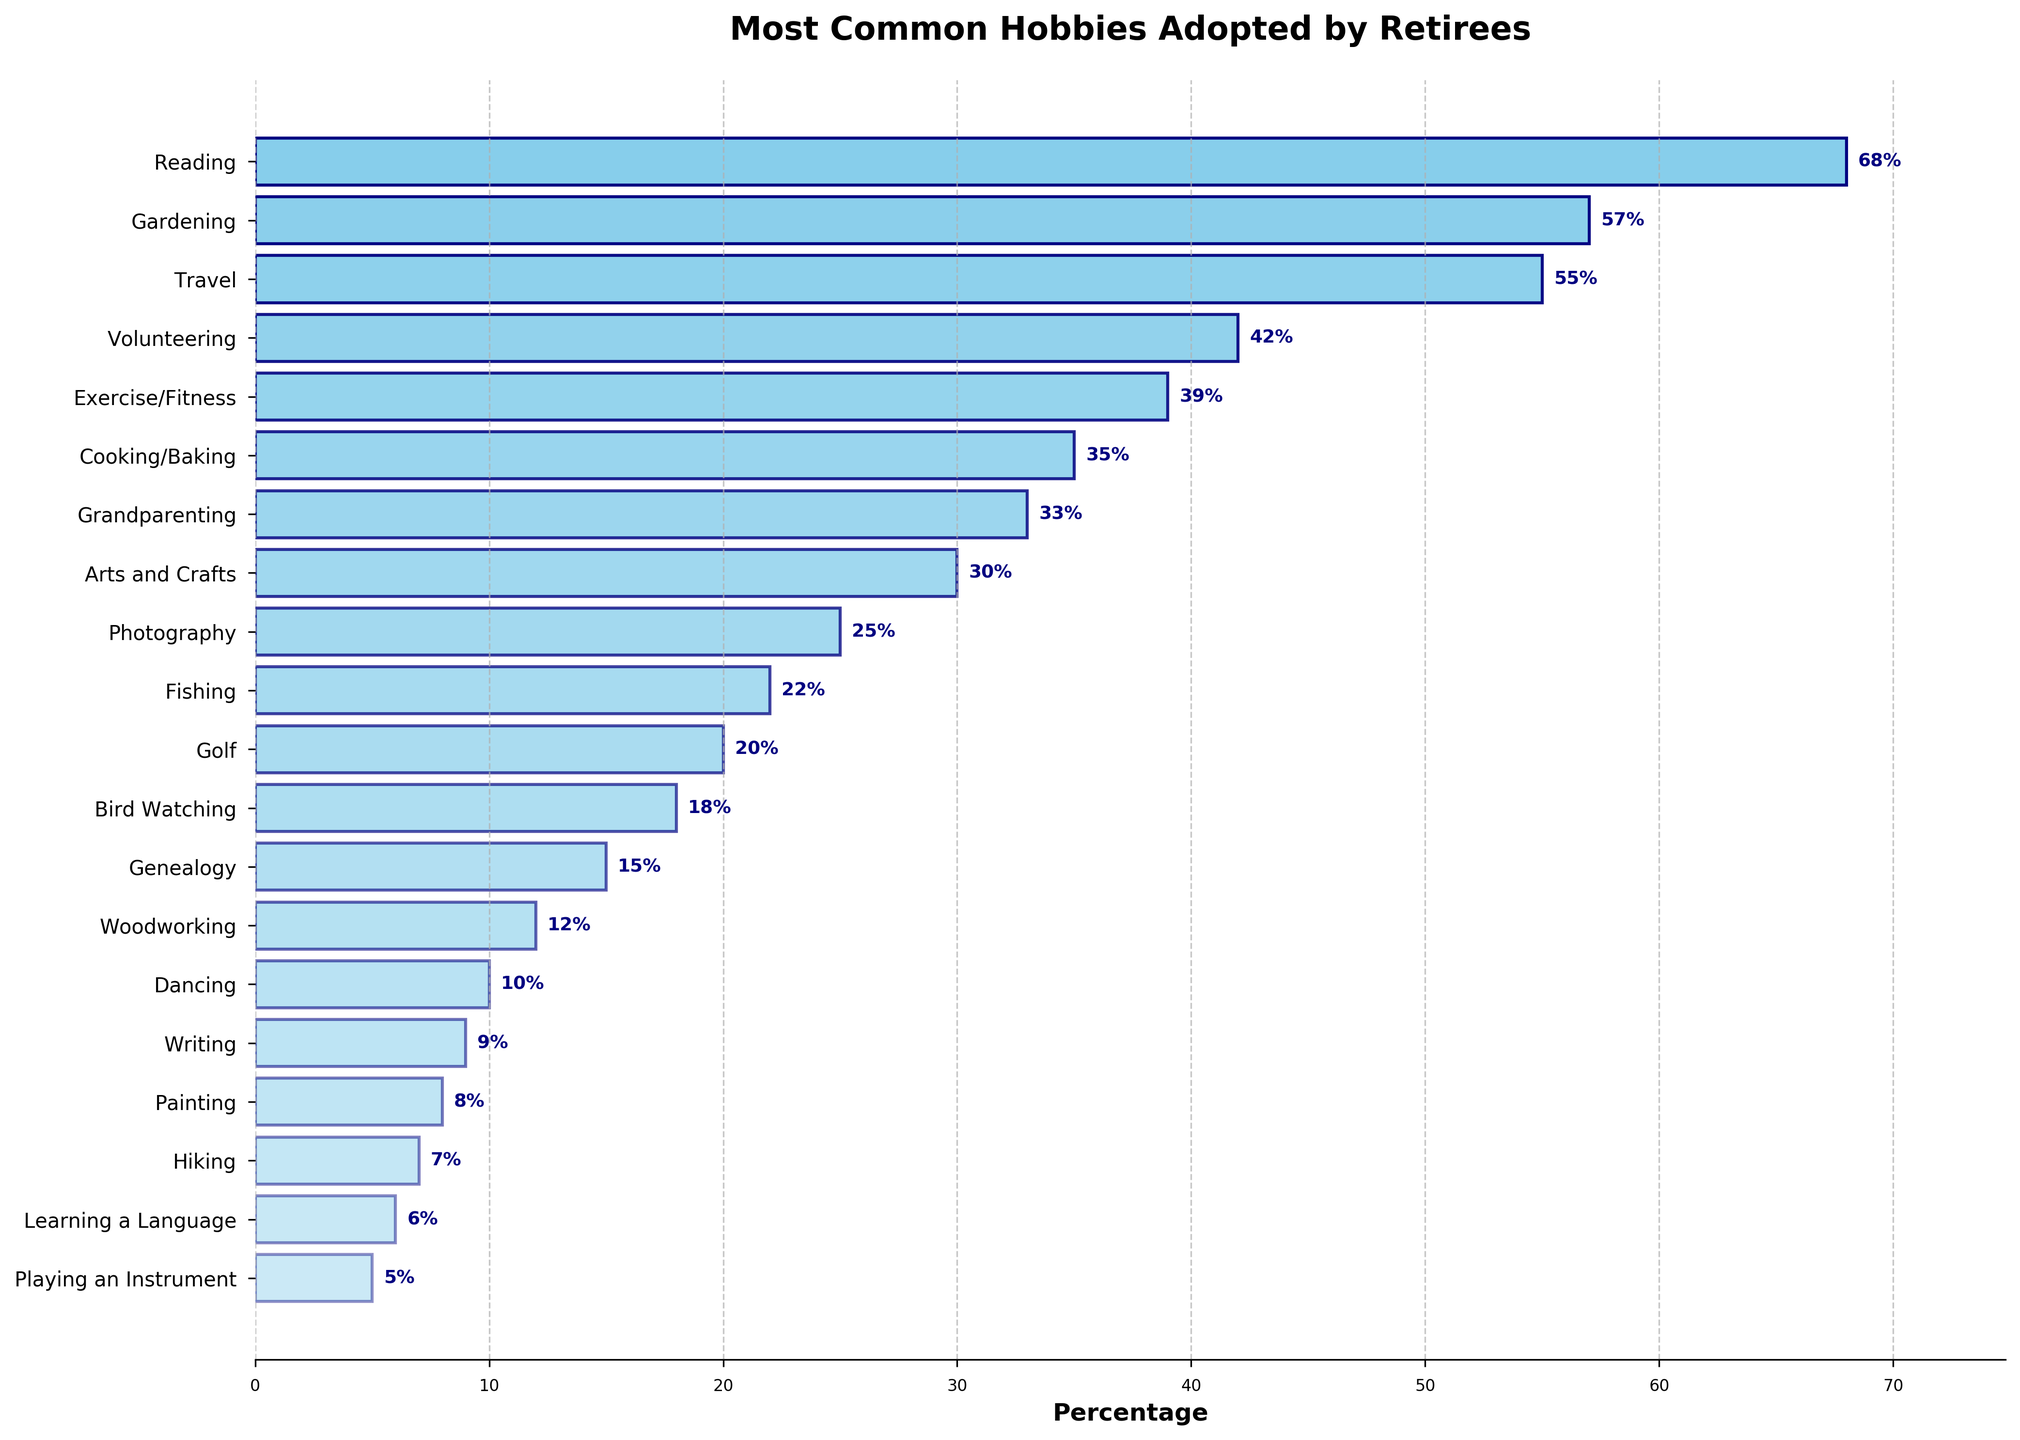Which hobby has the highest percentage of retirees participating? The first and tallest bar represents the hobby with the highest percentage.
Answer: Reading How many hobbies have a participation percentage higher than 50%? Count the bars whose lengths represent percentages higher than 50%.
Answer: 3 Which hobby has a slightly higher participation percentage, Gardening or Travel? Compare the lengths of the bars for Gardening and Travel.
Answer: Gardening What's the total participation percentage for the top three hobbies? Add the percentages of Reading, Gardening, and Travel: 68 + 57 + 55.
Answer: 180 Is there any hobby that has exactly 20% participation? Look for a bar with a length that corresponds to 20%.
Answer: Yes, Golf Do more retirees engage in Exercise/Fitness or Volunteering? Compare the lengths of the bars for Exercise/Fitness and Volunteering.
Answer: Volunteering What's the difference in participation percentage between the most and least common hobbies? Subtract the percentage of the least common hobby (Playing an Instrument, 5%) from the most common hobby (Reading, 68%).
Answer: 63 Which hobby has the second-lowest participation percentage? The next to last bar in terms of length represents the second-lowest participation.
Answer: Learning a Language What is the average participation percentage of hobbies listed? Add all percentages and divide by the number of hobbies (20): (68 + 57 + 55 + 42 + 39 + 35 + 33 + 30 + 25 + 22 + 20 + 18 + 15 + 12 + 10 + 9 + 8 + 7 + 6 + 5) / 20.
Answer: 26.9 Which hobbies have a participation percentage close to 10%? Look for bars whose lengths are near the 10% mark.
Answer: Dancing (10%), Writing (9%), Painting (8%) 